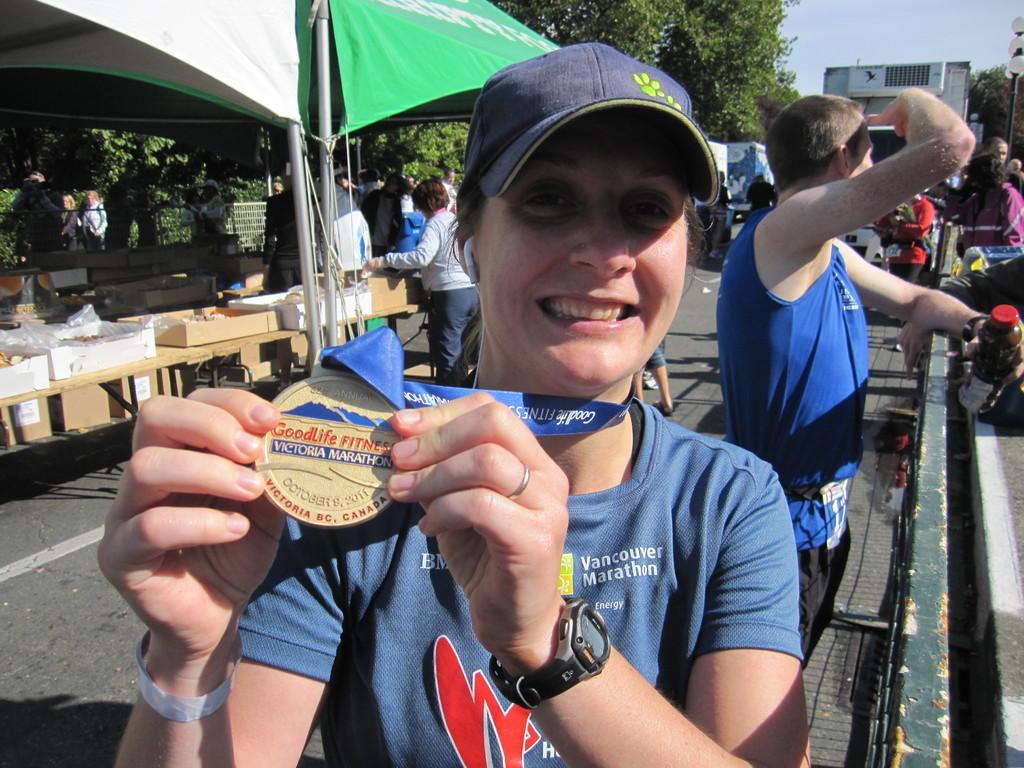Describe this image in one or two sentences. There is a lady wearing cap and watch is holding a medal with a ribbon. In the back there are many people. Also there is a tent. Below that there are tables. On the tables there are boxes. In the background there are trees, building and sky. 